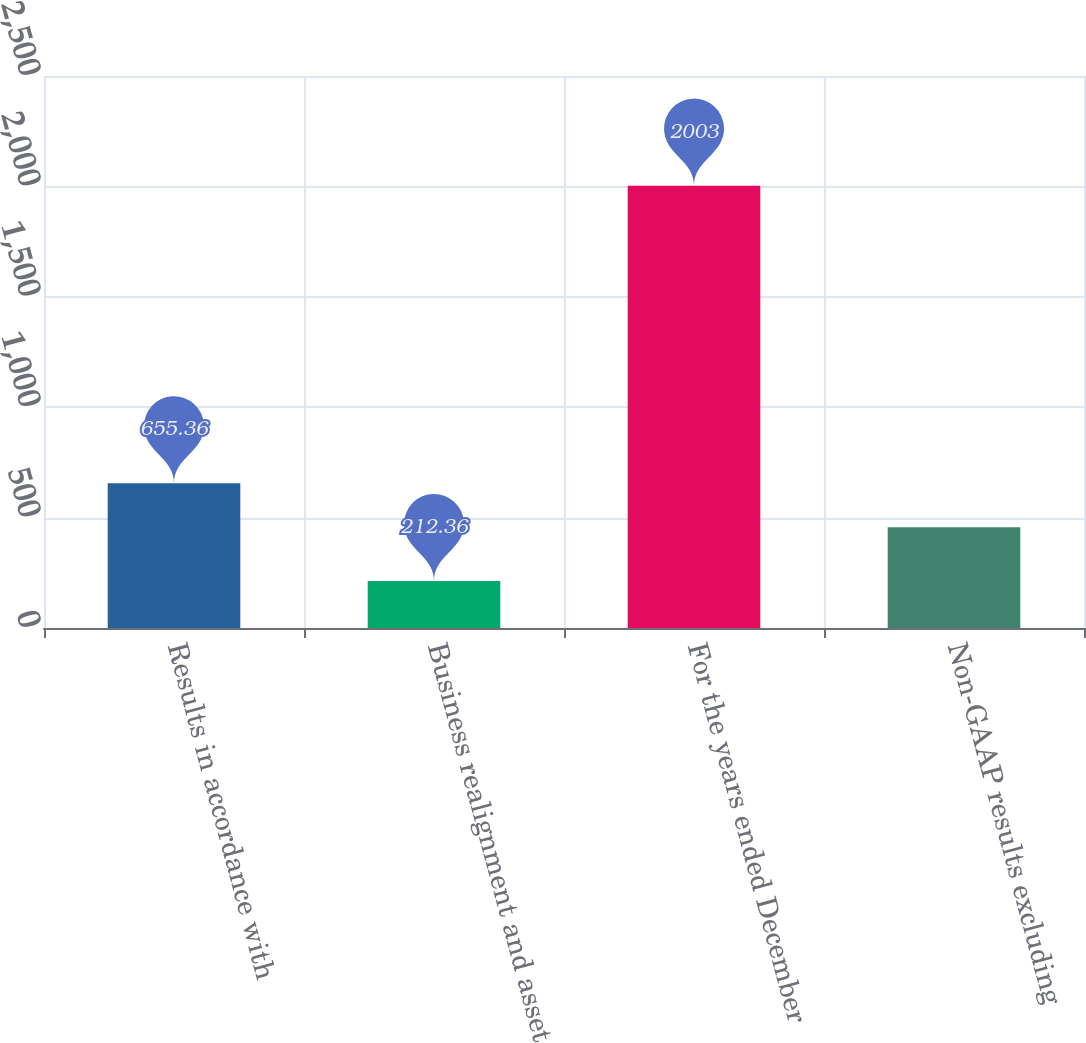<chart> <loc_0><loc_0><loc_500><loc_500><bar_chart><fcel>Results in accordance with<fcel>Business realignment and asset<fcel>For the years ended December<fcel>Non-GAAP results excluding<nl><fcel>655.36<fcel>212.36<fcel>2003<fcel>456.4<nl></chart> 